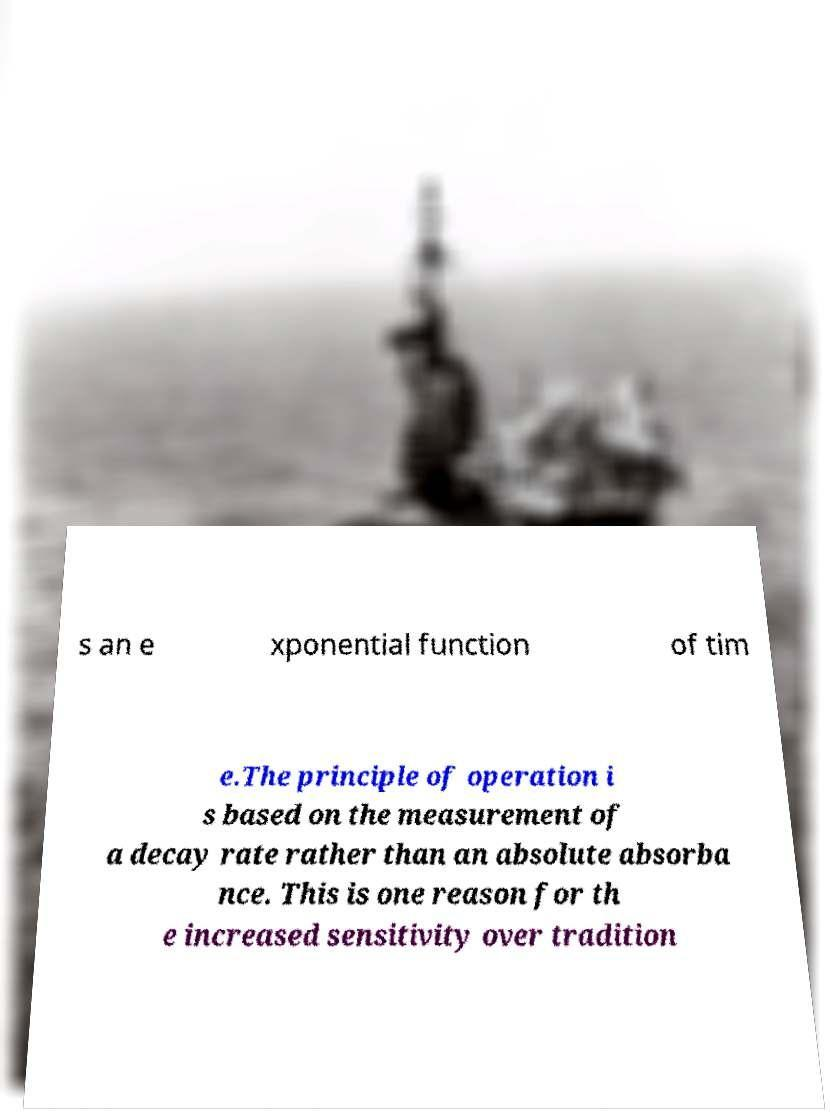Can you read and provide the text displayed in the image?This photo seems to have some interesting text. Can you extract and type it out for me? s an e xponential function of tim e.The principle of operation i s based on the measurement of a decay rate rather than an absolute absorba nce. This is one reason for th e increased sensitivity over tradition 